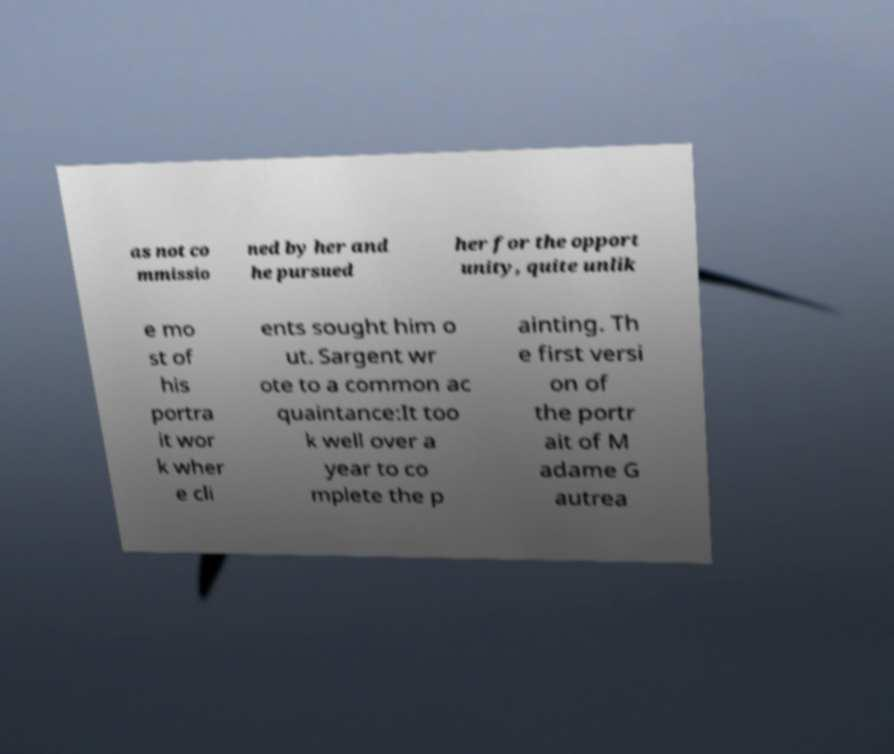For documentation purposes, I need the text within this image transcribed. Could you provide that? as not co mmissio ned by her and he pursued her for the opport unity, quite unlik e mo st of his portra it wor k wher e cli ents sought him o ut. Sargent wr ote to a common ac quaintance:It too k well over a year to co mplete the p ainting. Th e first versi on of the portr ait of M adame G autrea 